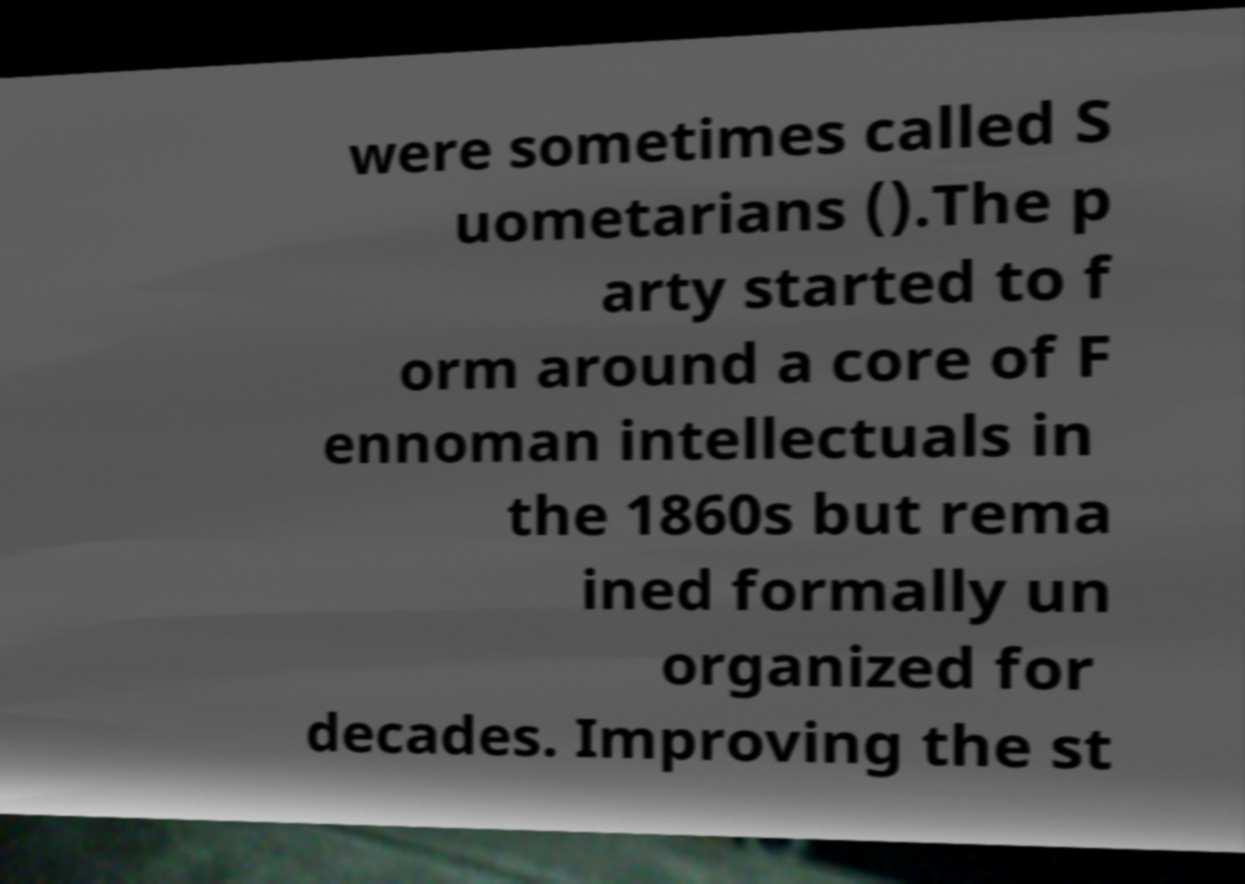What messages or text are displayed in this image? I need them in a readable, typed format. were sometimes called S uometarians ().The p arty started to f orm around a core of F ennoman intellectuals in the 1860s but rema ined formally un organized for decades. Improving the st 